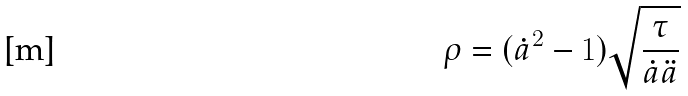Convert formula to latex. <formula><loc_0><loc_0><loc_500><loc_500>\rho & = ( \dot { a } ^ { 2 } - 1 ) \sqrt { \frac { \tau } { \dot { a } \ddot { a } } }</formula> 